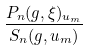<formula> <loc_0><loc_0><loc_500><loc_500>\frac { P _ { n } ( g , \xi ) _ { u _ { m } } } { S _ { n } ( g , u _ { m } ) }</formula> 